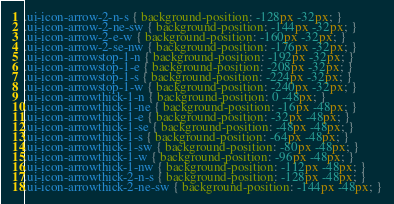Convert code to text. <code><loc_0><loc_0><loc_500><loc_500><_CSS_>.ui-icon-arrow-2-n-s { background-position: -128px -32px; }
.ui-icon-arrow-2-ne-sw { background-position: -144px -32px; }
.ui-icon-arrow-2-e-w { background-position: -160px -32px; }
.ui-icon-arrow-2-se-nw { background-position: -176px -32px; }
.ui-icon-arrowstop-1-n { background-position: -192px -32px; }
.ui-icon-arrowstop-1-e { background-position: -208px -32px; }
.ui-icon-arrowstop-1-s { background-position: -224px -32px; }
.ui-icon-arrowstop-1-w { background-position: -240px -32px; }
.ui-icon-arrowthick-1-n { background-position: 0 -48px; }
.ui-icon-arrowthick-1-ne { background-position: -16px -48px; }
.ui-icon-arrowthick-1-e { background-position: -32px -48px; }
.ui-icon-arrowthick-1-se { background-position: -48px -48px; }
.ui-icon-arrowthick-1-s { background-position: -64px -48px; }
.ui-icon-arrowthick-1-sw { background-position: -80px -48px; }
.ui-icon-arrowthick-1-w { background-position: -96px -48px; }
.ui-icon-arrowthick-1-nw { background-position: -112px -48px; }
.ui-icon-arrowthick-2-n-s { background-position: -128px -48px; }
.ui-icon-arrowthick-2-ne-sw { background-position: -144px -48px; }</code> 